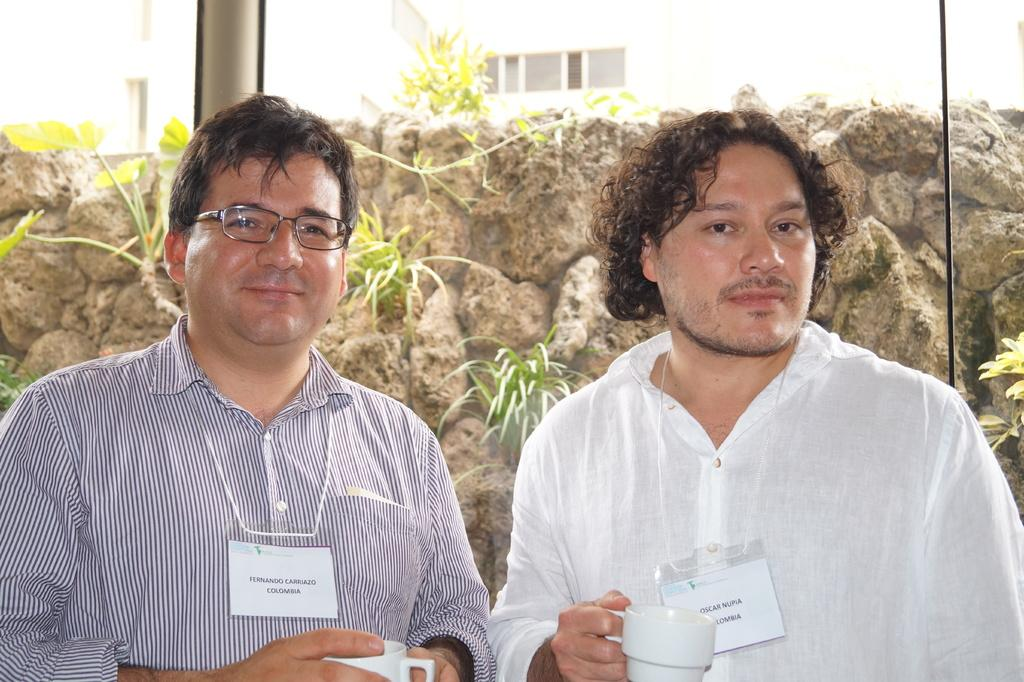How many people are in the image? There are two people in the foreground of the image. What are the people holding in their hands? Both people are holding cups. What can be seen in the background of the image? There is a rod, plants, and rocks visible in the background of the image. What type of channel can be seen running through the rocks in the image? There is no channel visible in the image; only rocks, plants, and a rod can be seen in the background. 